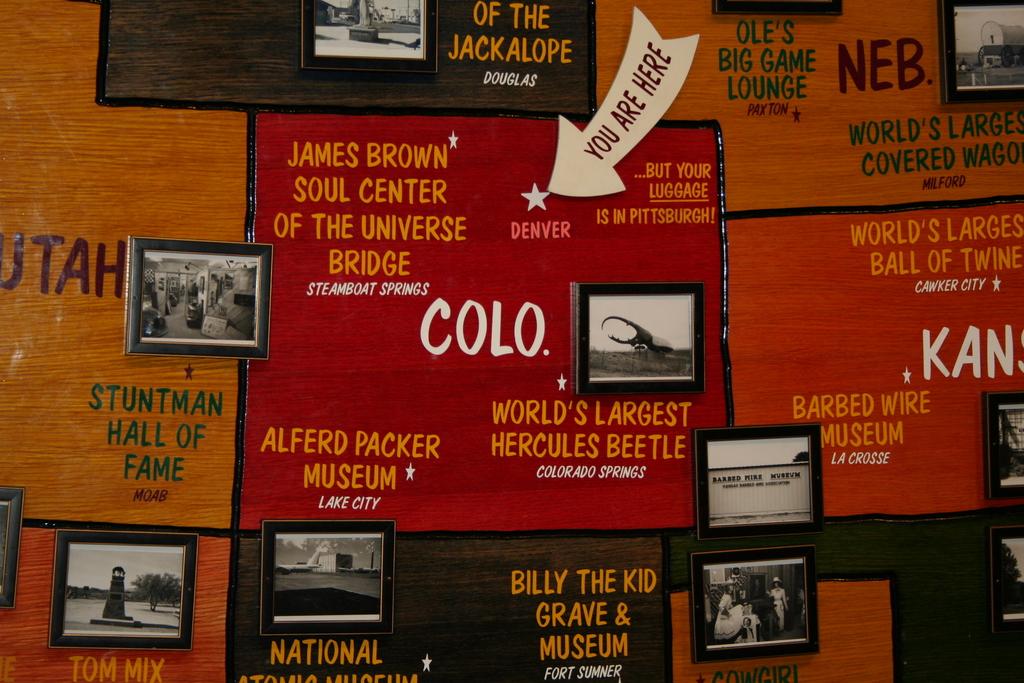Where are you?
Make the answer very short. Denver. What is advertised as being the world's largest?
Keep it short and to the point. Hercules beetle. 